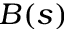<formula> <loc_0><loc_0><loc_500><loc_500>B ( s )</formula> 